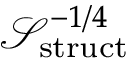<formula> <loc_0><loc_0><loc_500><loc_500>{ \mathcal { S } } _ { s t r u c t } ^ { - 1 / 4 }</formula> 